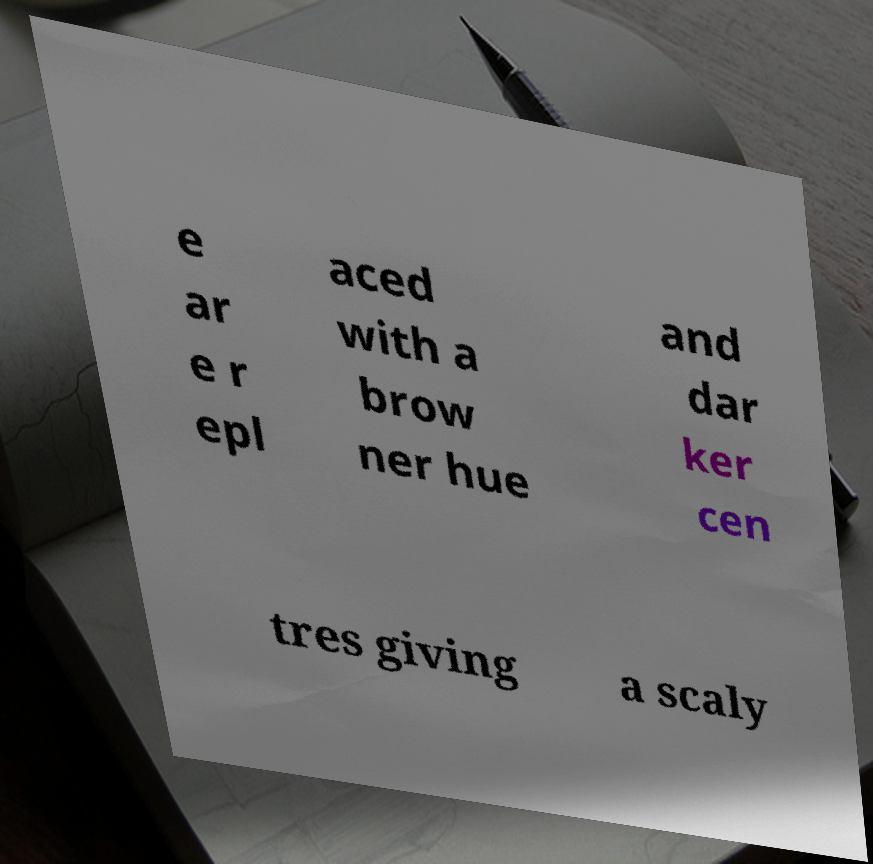I need the written content from this picture converted into text. Can you do that? e ar e r epl aced with a brow ner hue and dar ker cen tres giving a scaly 